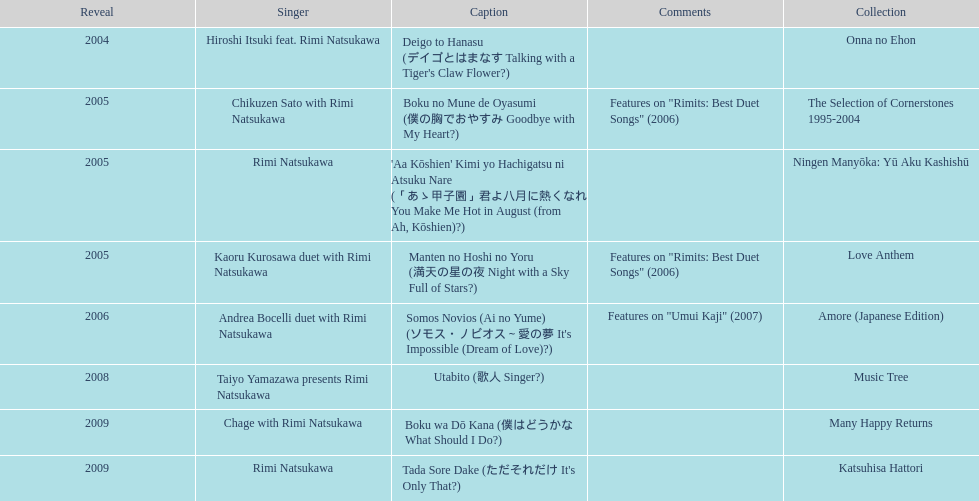Which was not released in 2004, onna no ehon or music tree? Music Tree. 